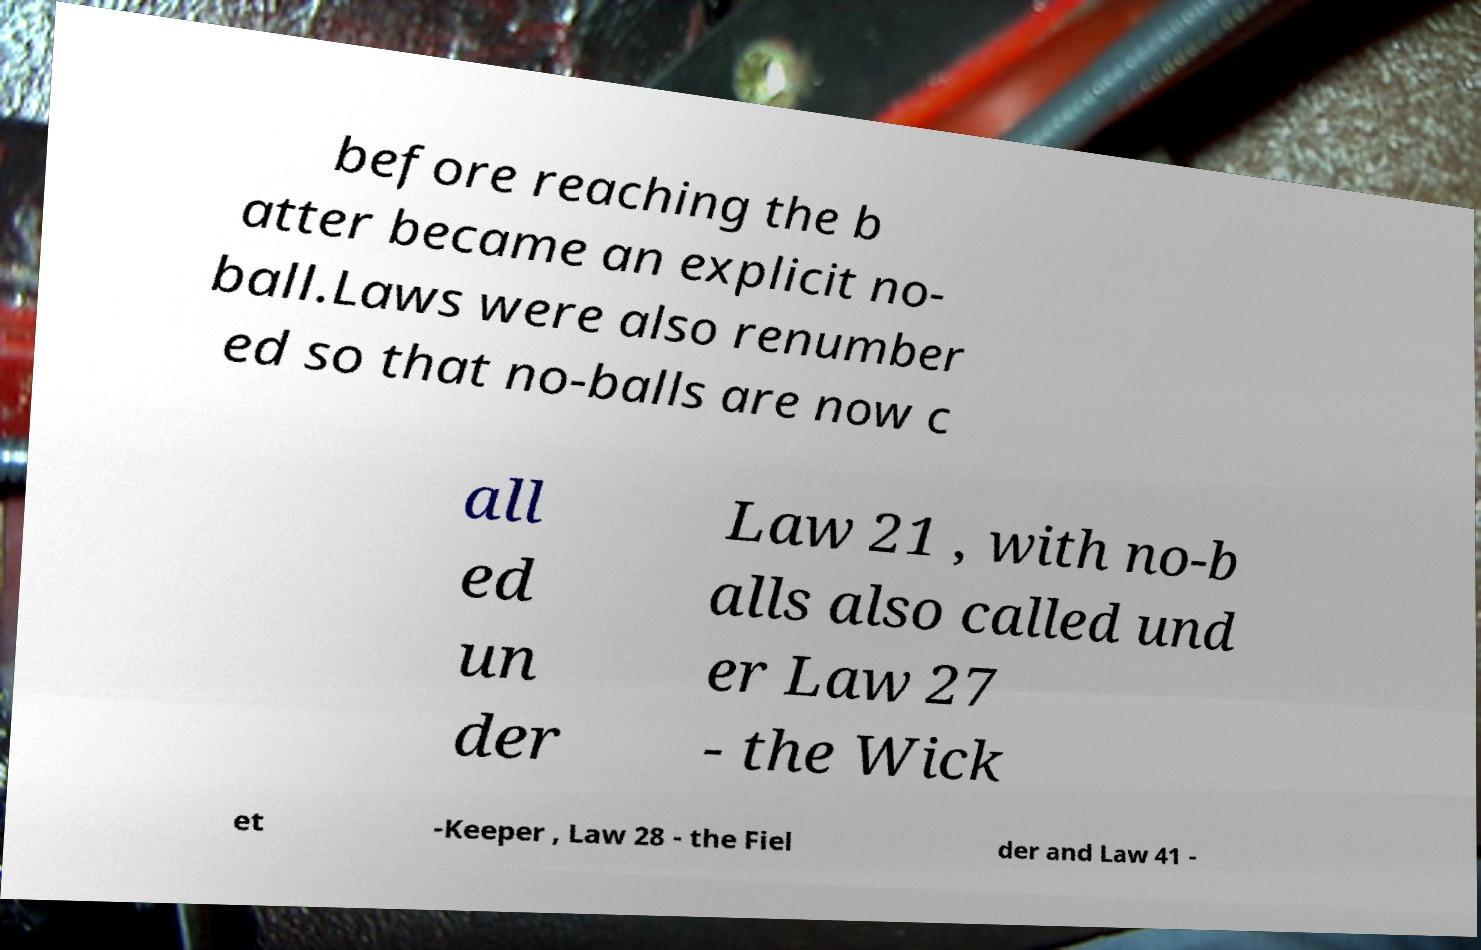Could you extract and type out the text from this image? before reaching the b atter became an explicit no- ball.Laws were also renumber ed so that no-balls are now c all ed un der Law 21 , with no-b alls also called und er Law 27 - the Wick et -Keeper , Law 28 - the Fiel der and Law 41 - 